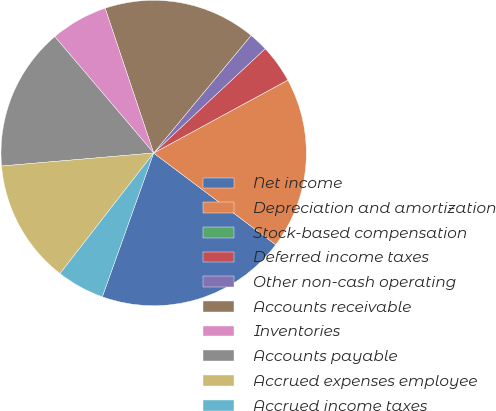<chart> <loc_0><loc_0><loc_500><loc_500><pie_chart><fcel>Net income<fcel>Depreciation and amortization<fcel>Stock-based compensation<fcel>Deferred income taxes<fcel>Other non-cash operating<fcel>Accounts receivable<fcel>Inventories<fcel>Accounts payable<fcel>Accrued expenses employee<fcel>Accrued income taxes<nl><fcel>20.2%<fcel>18.18%<fcel>0.0%<fcel>4.04%<fcel>2.02%<fcel>16.16%<fcel>6.06%<fcel>15.15%<fcel>13.13%<fcel>5.05%<nl></chart> 